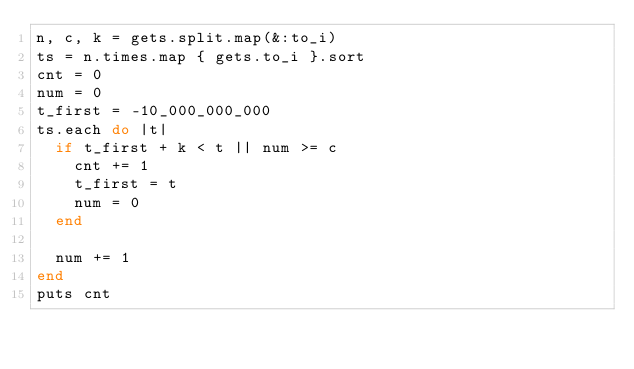Convert code to text. <code><loc_0><loc_0><loc_500><loc_500><_Ruby_>n, c, k = gets.split.map(&:to_i)
ts = n.times.map { gets.to_i }.sort
cnt = 0
num = 0
t_first = -10_000_000_000
ts.each do |t|
  if t_first + k < t || num >= c
    cnt += 1
    t_first = t
    num = 0
  end

  num += 1
end
puts cnt
</code> 